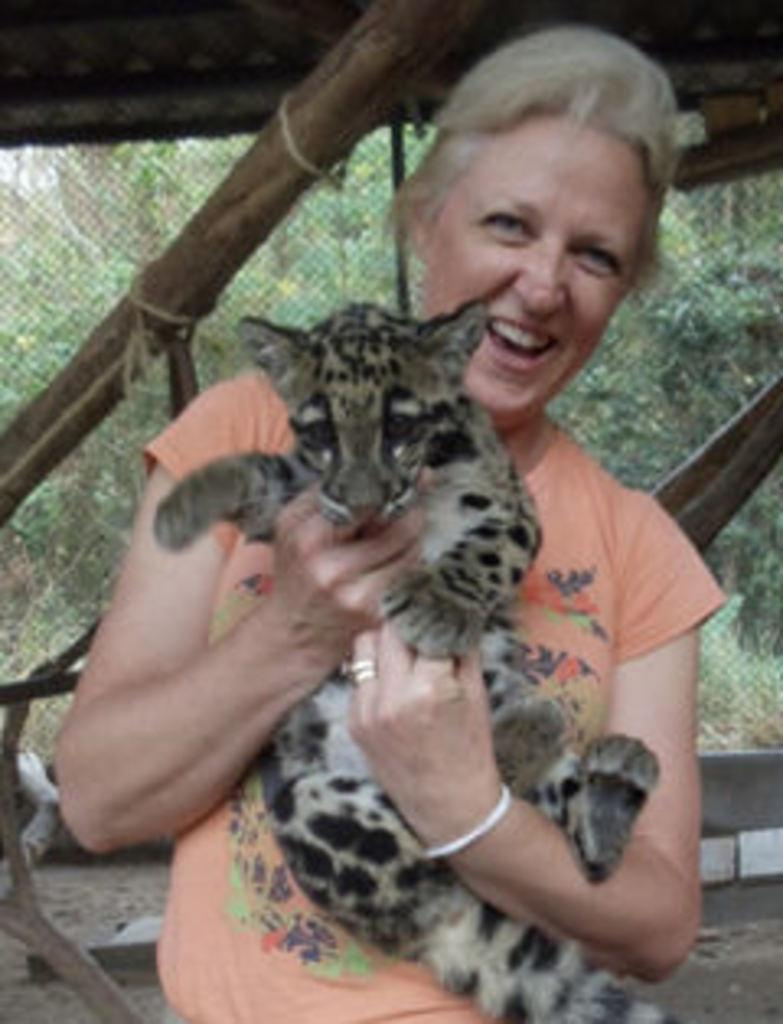Who is the main subject in the image? There is a woman in the image. What is the woman doing in the image? The woman is holding a cat with her hands. What is the woman's facial expression in the image? The woman is smiling. What can be seen in the background of the image? There is a mesh and trees in the background of the image. What type of butter is the woman using to pet the cat in the image? There is no butter present in the image, and the woman is using her hands to hold the cat. 